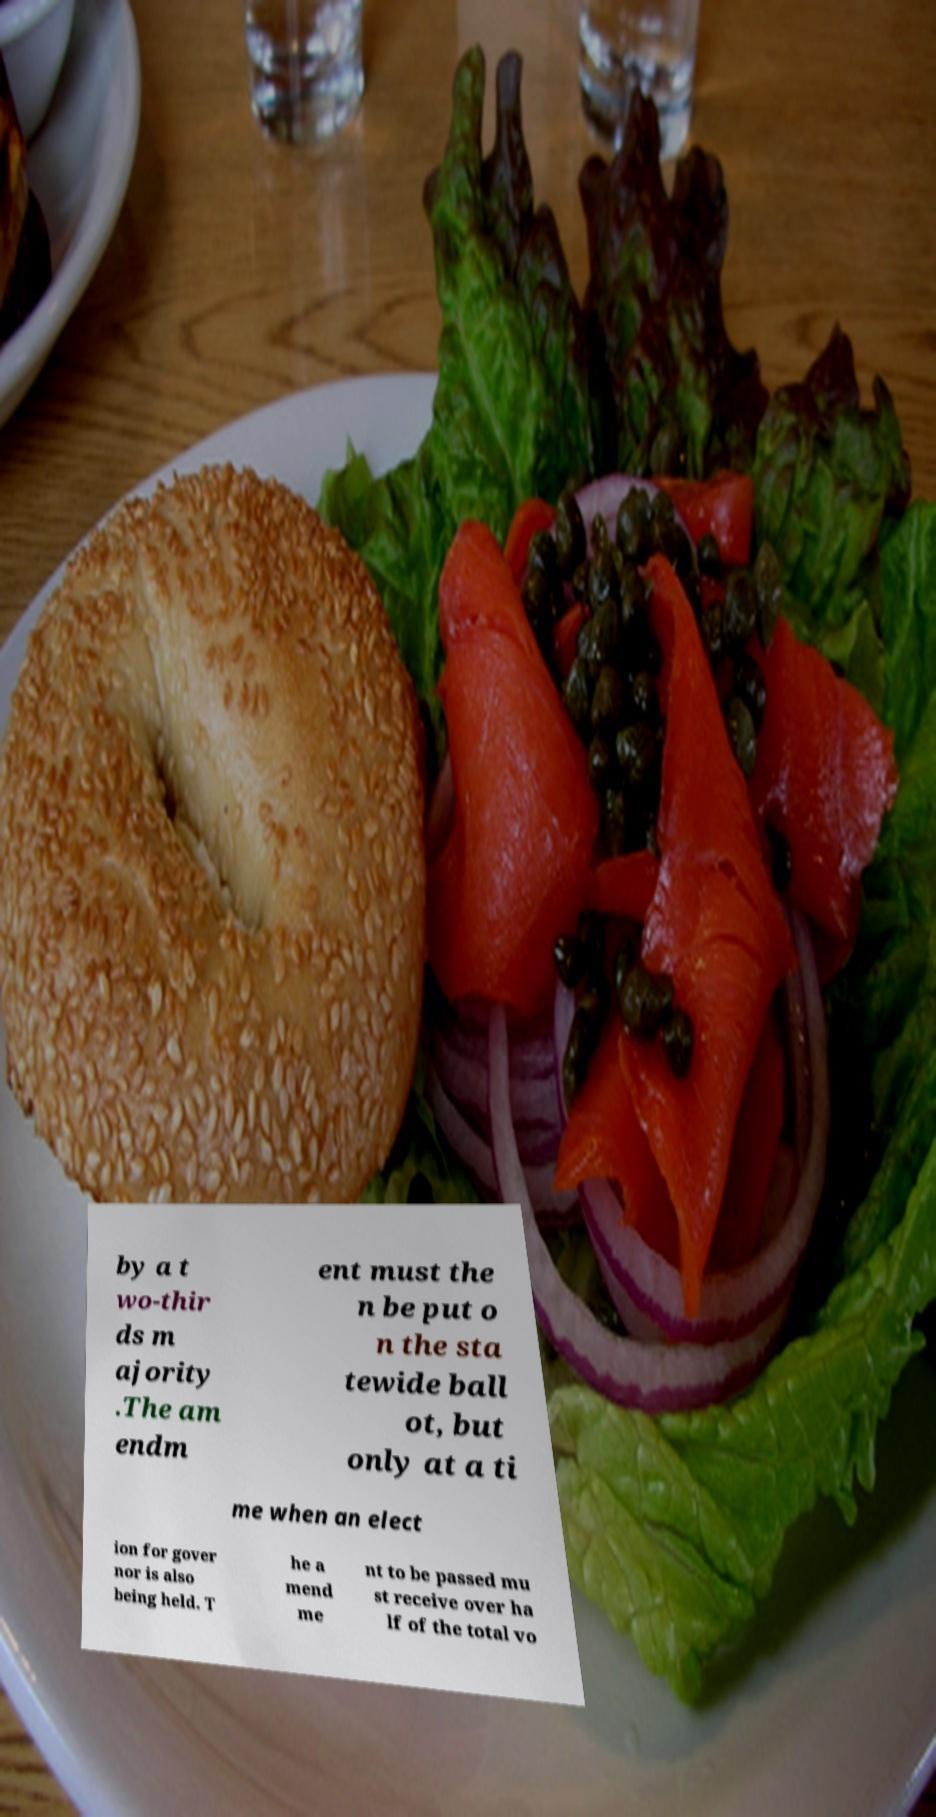For documentation purposes, I need the text within this image transcribed. Could you provide that? by a t wo-thir ds m ajority .The am endm ent must the n be put o n the sta tewide ball ot, but only at a ti me when an elect ion for gover nor is also being held. T he a mend me nt to be passed mu st receive over ha lf of the total vo 